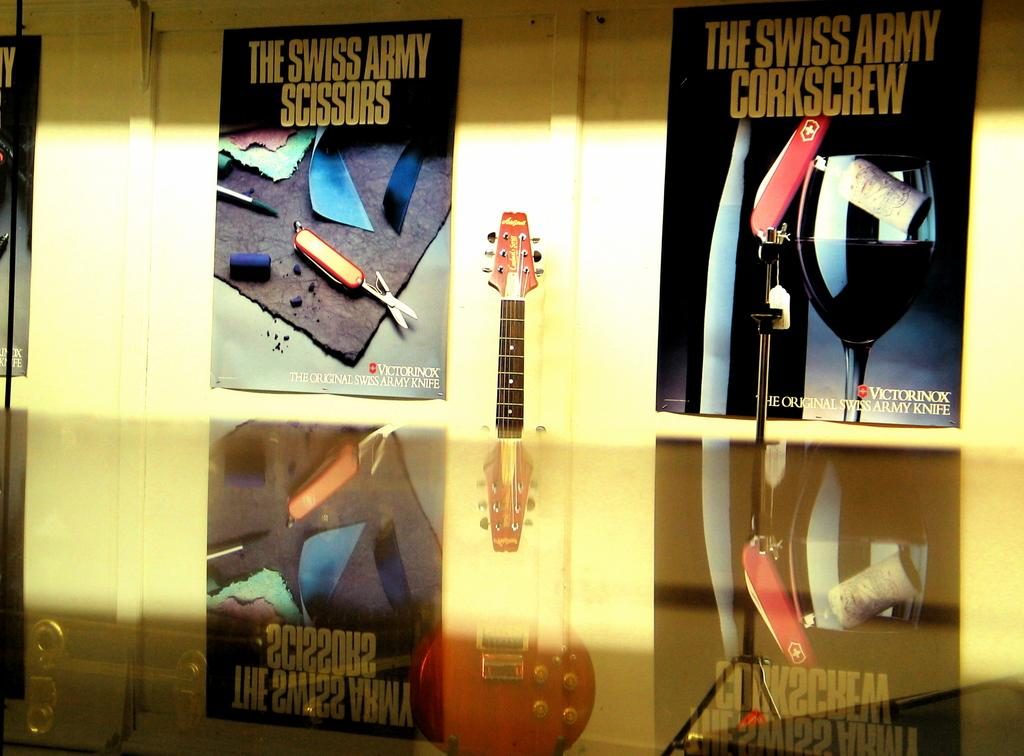<image>
Offer a succinct explanation of the picture presented. The Swiss Army Scissors, and the Swiss Army Corkscrew on a posterboard. 